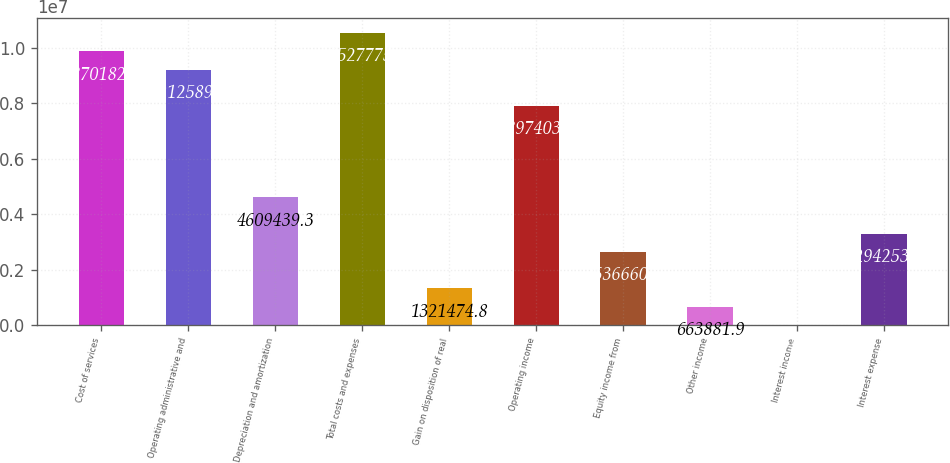Convert chart to OTSL. <chart><loc_0><loc_0><loc_500><loc_500><bar_chart><fcel>Cost of services<fcel>Operating administrative and<fcel>Depreciation and amortization<fcel>Total costs and expenses<fcel>Gain on disposition of real<fcel>Operating income<fcel>Equity income from<fcel>Other income<fcel>Interest income<fcel>Interest expense<nl><fcel>9.87018e+06<fcel>9.21259e+06<fcel>4.60944e+06<fcel>1.05278e+07<fcel>1.32147e+06<fcel>7.8974e+06<fcel>2.63666e+06<fcel>663882<fcel>6289<fcel>3.29425e+06<nl></chart> 